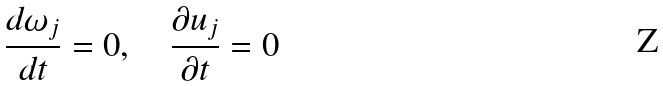Convert formula to latex. <formula><loc_0><loc_0><loc_500><loc_500>\frac { d \omega _ { j } } { d t } = 0 , \quad \frac { \partial u _ { j } } { \partial t } = 0</formula> 